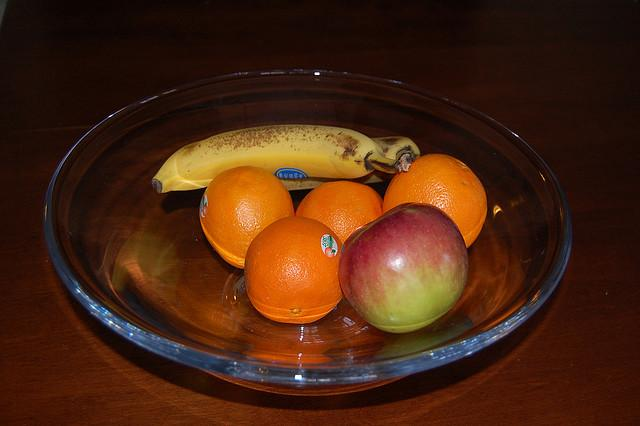What type of fruit is at the front of this fruit basket ahead of all of the oranges?

Choices:
A) banana
B) apple
C) pineapple
D) pear apple 